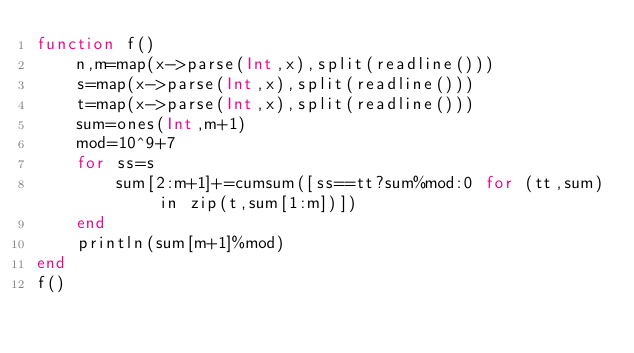Convert code to text. <code><loc_0><loc_0><loc_500><loc_500><_Julia_>function f()
	n,m=map(x->parse(Int,x),split(readline()))
	s=map(x->parse(Int,x),split(readline()))
	t=map(x->parse(Int,x),split(readline()))
	sum=ones(Int,m+1)
	mod=10^9+7
	for ss=s
		sum[2:m+1]+=cumsum([ss==tt?sum%mod:0 for (tt,sum) in zip(t,sum[1:m])])
	end
	println(sum[m+1]%mod)
end
f()</code> 